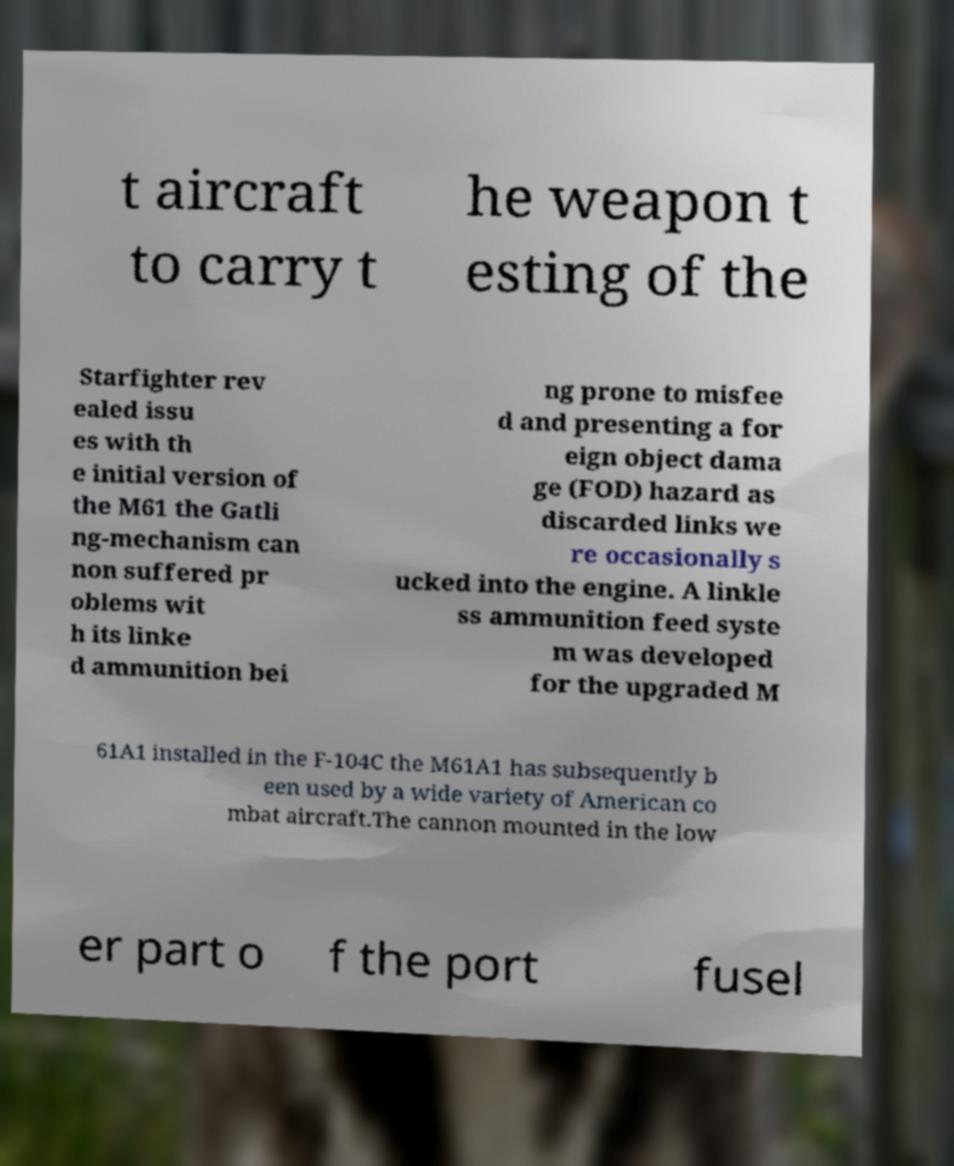Please identify and transcribe the text found in this image. t aircraft to carry t he weapon t esting of the Starfighter rev ealed issu es with th e initial version of the M61 the Gatli ng-mechanism can non suffered pr oblems wit h its linke d ammunition bei ng prone to misfee d and presenting a for eign object dama ge (FOD) hazard as discarded links we re occasionally s ucked into the engine. A linkle ss ammunition feed syste m was developed for the upgraded M 61A1 installed in the F-104C the M61A1 has subsequently b een used by a wide variety of American co mbat aircraft.The cannon mounted in the low er part o f the port fusel 